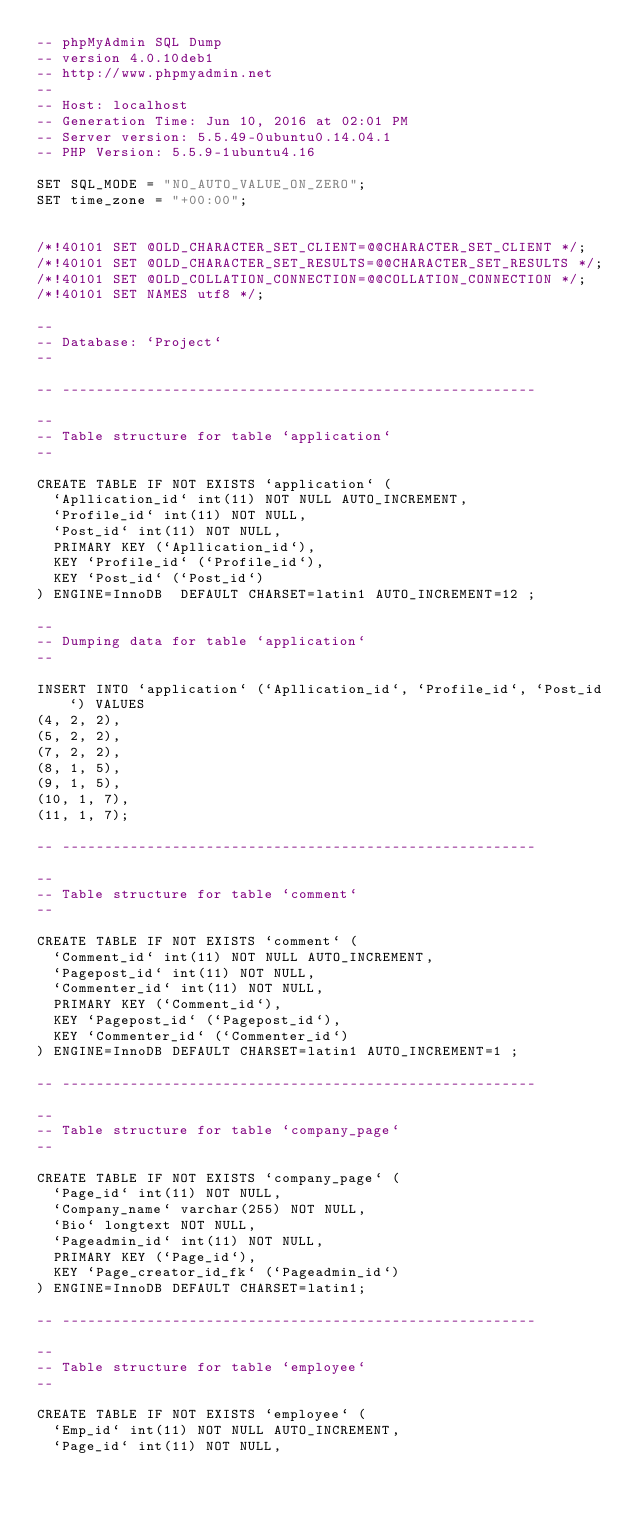Convert code to text. <code><loc_0><loc_0><loc_500><loc_500><_SQL_>-- phpMyAdmin SQL Dump
-- version 4.0.10deb1
-- http://www.phpmyadmin.net
--
-- Host: localhost
-- Generation Time: Jun 10, 2016 at 02:01 PM
-- Server version: 5.5.49-0ubuntu0.14.04.1
-- PHP Version: 5.5.9-1ubuntu4.16

SET SQL_MODE = "NO_AUTO_VALUE_ON_ZERO";
SET time_zone = "+00:00";


/*!40101 SET @OLD_CHARACTER_SET_CLIENT=@@CHARACTER_SET_CLIENT */;
/*!40101 SET @OLD_CHARACTER_SET_RESULTS=@@CHARACTER_SET_RESULTS */;
/*!40101 SET @OLD_COLLATION_CONNECTION=@@COLLATION_CONNECTION */;
/*!40101 SET NAMES utf8 */;

--
-- Database: `Project`
--

-- --------------------------------------------------------

--
-- Table structure for table `application`
--

CREATE TABLE IF NOT EXISTS `application` (
  `Apllication_id` int(11) NOT NULL AUTO_INCREMENT,
  `Profile_id` int(11) NOT NULL,
  `Post_id` int(11) NOT NULL,
  PRIMARY KEY (`Apllication_id`),
  KEY `Profile_id` (`Profile_id`),
  KEY `Post_id` (`Post_id`)
) ENGINE=InnoDB  DEFAULT CHARSET=latin1 AUTO_INCREMENT=12 ;

--
-- Dumping data for table `application`
--

INSERT INTO `application` (`Apllication_id`, `Profile_id`, `Post_id`) VALUES
(4, 2, 2),
(5, 2, 2),
(7, 2, 2),
(8, 1, 5),
(9, 1, 5),
(10, 1, 7),
(11, 1, 7);

-- --------------------------------------------------------

--
-- Table structure for table `comment`
--

CREATE TABLE IF NOT EXISTS `comment` (
  `Comment_id` int(11) NOT NULL AUTO_INCREMENT,
  `Pagepost_id` int(11) NOT NULL,
  `Commenter_id` int(11) NOT NULL,
  PRIMARY KEY (`Comment_id`),
  KEY `Pagepost_id` (`Pagepost_id`),
  KEY `Commenter_id` (`Commenter_id`)
) ENGINE=InnoDB DEFAULT CHARSET=latin1 AUTO_INCREMENT=1 ;

-- --------------------------------------------------------

--
-- Table structure for table `company_page`
--

CREATE TABLE IF NOT EXISTS `company_page` (
  `Page_id` int(11) NOT NULL,
  `Company_name` varchar(255) NOT NULL,
  `Bio` longtext NOT NULL,
  `Pageadmin_id` int(11) NOT NULL,
  PRIMARY KEY (`Page_id`),
  KEY `Page_creator_id_fk` (`Pageadmin_id`)
) ENGINE=InnoDB DEFAULT CHARSET=latin1;

-- --------------------------------------------------------

--
-- Table structure for table `employee`
--

CREATE TABLE IF NOT EXISTS `employee` (
  `Emp_id` int(11) NOT NULL AUTO_INCREMENT,
  `Page_id` int(11) NOT NULL,</code> 